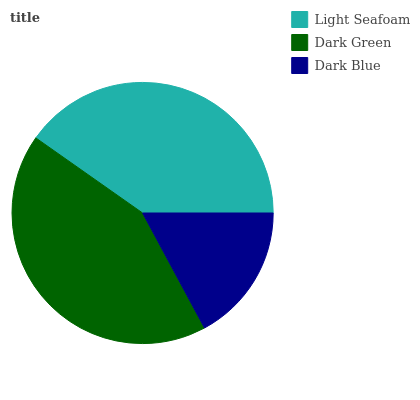Is Dark Blue the minimum?
Answer yes or no. Yes. Is Dark Green the maximum?
Answer yes or no. Yes. Is Dark Green the minimum?
Answer yes or no. No. Is Dark Blue the maximum?
Answer yes or no. No. Is Dark Green greater than Dark Blue?
Answer yes or no. Yes. Is Dark Blue less than Dark Green?
Answer yes or no. Yes. Is Dark Blue greater than Dark Green?
Answer yes or no. No. Is Dark Green less than Dark Blue?
Answer yes or no. No. Is Light Seafoam the high median?
Answer yes or no. Yes. Is Light Seafoam the low median?
Answer yes or no. Yes. Is Dark Blue the high median?
Answer yes or no. No. Is Dark Green the low median?
Answer yes or no. No. 